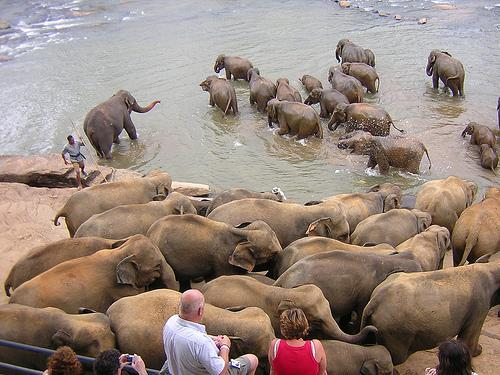What is the main animal in the image, and what is it doing? The main animal in the image is a group of grey elephants, and they are playing in the water. What is the collective mood or sentiment of the people in this image? The people in the image seem to be fascinated and engaged while watching the elephants playing in the water. Discuss any object or person associated with photography in this photo. There is a person with black hair taking a photograph of the elephants using a camera in their hands. Provide a description of two notable people in the image and their clothing. There is a man with very little white hair wearing a white shirt and a woman wearing a red tank top with white straps showing, both observing the elephants. Explain the activity of the man who seems to be holding something in his hand. The man is carrying a large brown stick, which appears to be a wooden pole, possibly to interact with or manage the elephants. In this image, describe the scene involving multiple elephants and water. There are numerous elephants in the water, some spraying water with their trunks, and others heading into the water, surrounded by small rocks and ripples on the water surface. Count the total number of elephants in the image. It is impossible to provide an exact count based on the text information provided. The image depicts a large group of elephants and a herd of elephants in the water. Please describe any humans interacting with the animals in the image. There are people watching the elephants, a man carrying a large brown stick, a person taking a photograph of elephants, and a man standing near the elephants in the water. Describe any elements related to the body of water in the image. The body of water has small rocks, ripples on the surface, white waves, reflections, and the elephants playing and spraying water in it. 